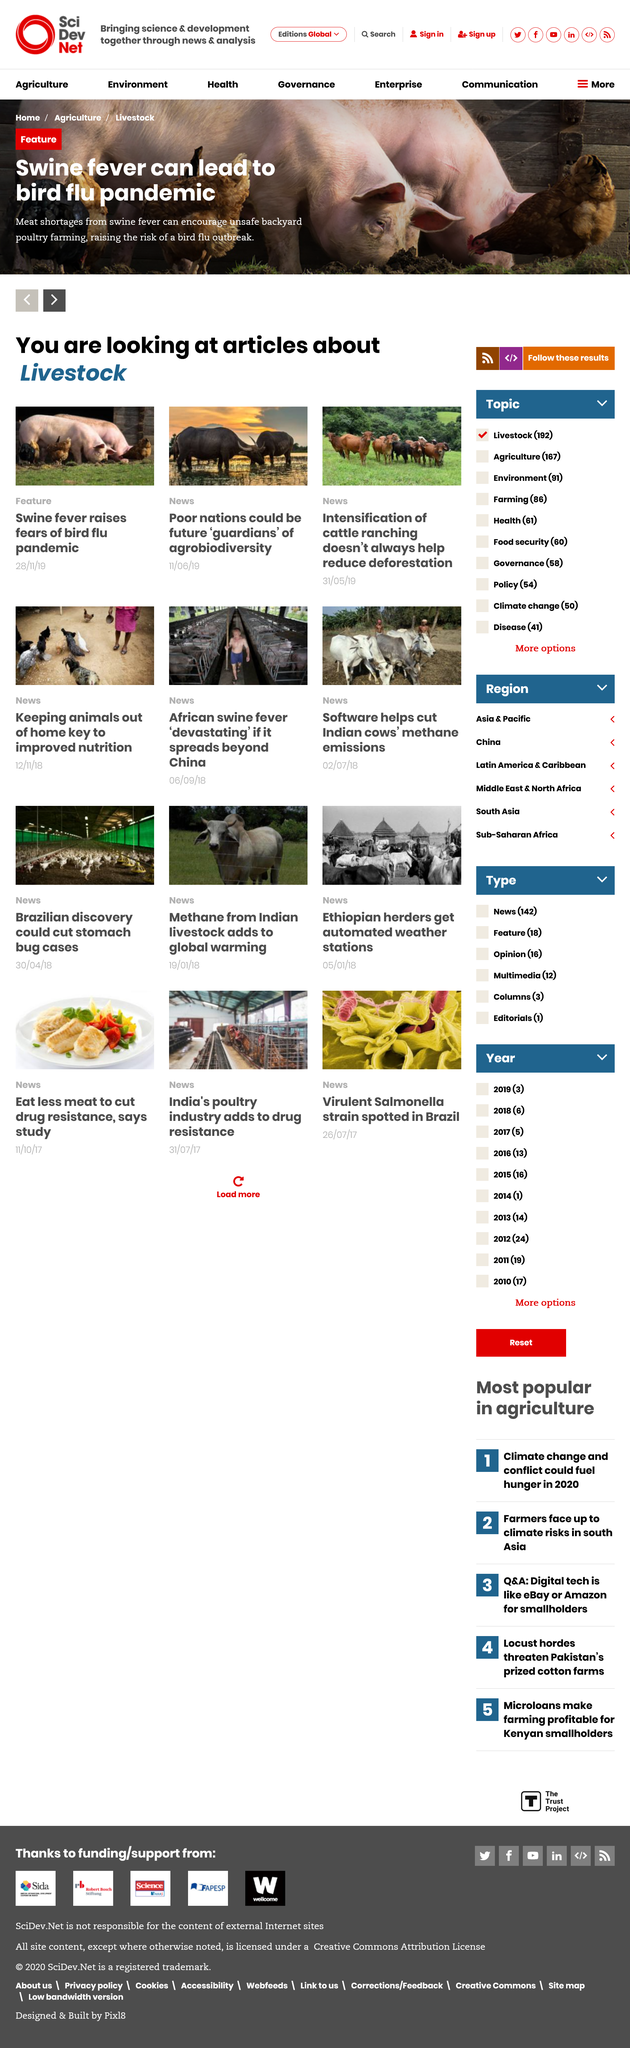Outline some significant characteristics in this image. The article on poor nations and agrobiodiversity falls under the News category. According to the feature title, swine fever has the potential to lead to a bird flu pandemic. On November 28, 2019, an article on swine fever raised fears of a bird flu pandemic. 